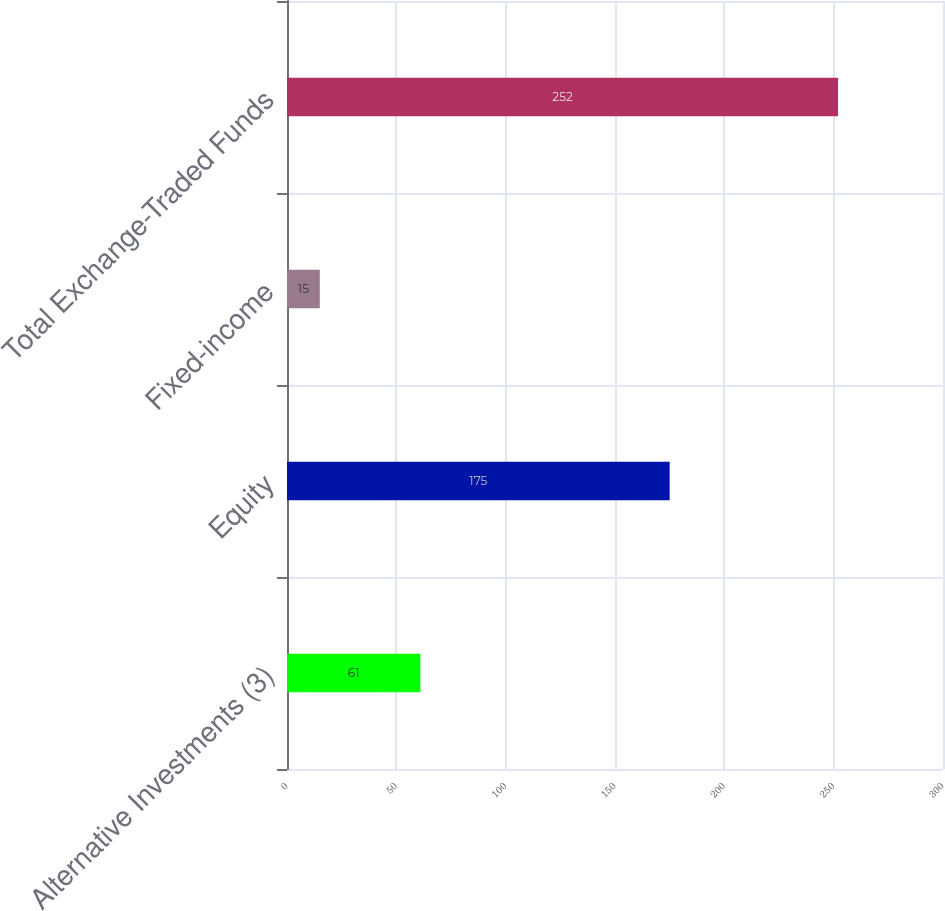<chart> <loc_0><loc_0><loc_500><loc_500><bar_chart><fcel>Alternative Investments (3)<fcel>Equity<fcel>Fixed-income<fcel>Total Exchange-Traded Funds<nl><fcel>61<fcel>175<fcel>15<fcel>252<nl></chart> 